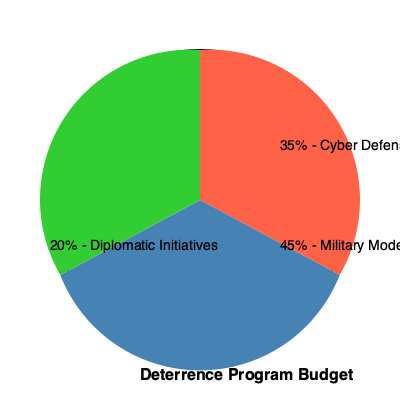Based on the pie chart showing the budget allocation for different deterrence programs, which area receives the largest portion of funding, and by how much does it exceed the smallest allocation? To answer this question, we need to follow these steps:

1. Identify the largest budget allocation:
   - Cyber Defense: 35%
   - Military Modernization: 45%
   - Diplomatic Initiatives: 20%
   The largest allocation is Military Modernization at 45%.

2. Identify the smallest budget allocation:
   The smallest allocation is Diplomatic Initiatives at 20%.

3. Calculate the difference between the largest and smallest allocations:
   $45\% - 20\% = 25\%$

Therefore, Military Modernization receives the largest portion of funding, and it exceeds the smallest allocation (Diplomatic Initiatives) by 25 percentage points.
Answer: Military Modernization; 25 percentage points 